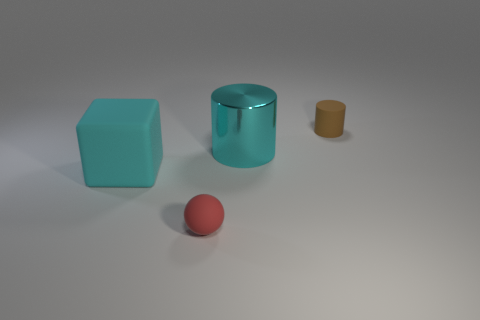There is a large block that is the same color as the large metal thing; what is it made of?
Offer a very short reply. Rubber. How many rubber objects are either small balls or small things?
Provide a succinct answer. 2. Is the tiny cylinder made of the same material as the large cyan block?
Offer a terse response. Yes. What is the material of the cyan object on the right side of the rubber thing that is in front of the cyan matte cube?
Offer a terse response. Metal. What number of tiny objects are rubber spheres or brown shiny spheres?
Keep it short and to the point. 1. The cyan matte block is what size?
Provide a short and direct response. Large. Is the number of matte blocks that are behind the large rubber thing greater than the number of large cylinders?
Make the answer very short. No. Are there an equal number of brown objects in front of the brown rubber thing and rubber cubes that are behind the large cyan cylinder?
Your answer should be compact. Yes. What is the color of the matte thing that is both on the right side of the cyan matte object and in front of the shiny object?
Keep it short and to the point. Red. Is there anything else that is the same size as the red ball?
Your response must be concise. Yes. 